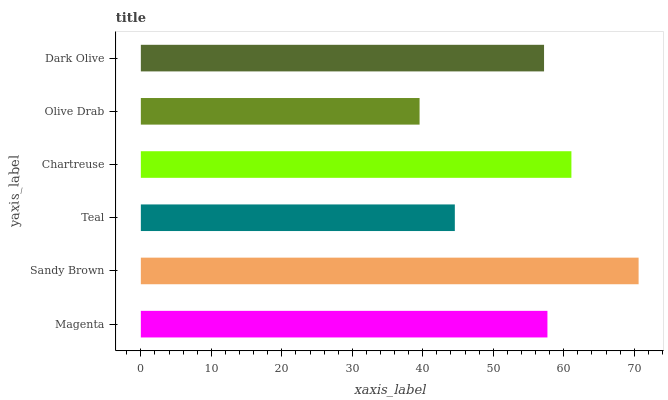Is Olive Drab the minimum?
Answer yes or no. Yes. Is Sandy Brown the maximum?
Answer yes or no. Yes. Is Teal the minimum?
Answer yes or no. No. Is Teal the maximum?
Answer yes or no. No. Is Sandy Brown greater than Teal?
Answer yes or no. Yes. Is Teal less than Sandy Brown?
Answer yes or no. Yes. Is Teal greater than Sandy Brown?
Answer yes or no. No. Is Sandy Brown less than Teal?
Answer yes or no. No. Is Magenta the high median?
Answer yes or no. Yes. Is Dark Olive the low median?
Answer yes or no. Yes. Is Sandy Brown the high median?
Answer yes or no. No. Is Olive Drab the low median?
Answer yes or no. No. 